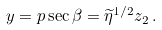<formula> <loc_0><loc_0><loc_500><loc_500>y = p \sec \beta = \widetilde { \eta } ^ { 1 / 2 } z _ { 2 } \, .</formula> 